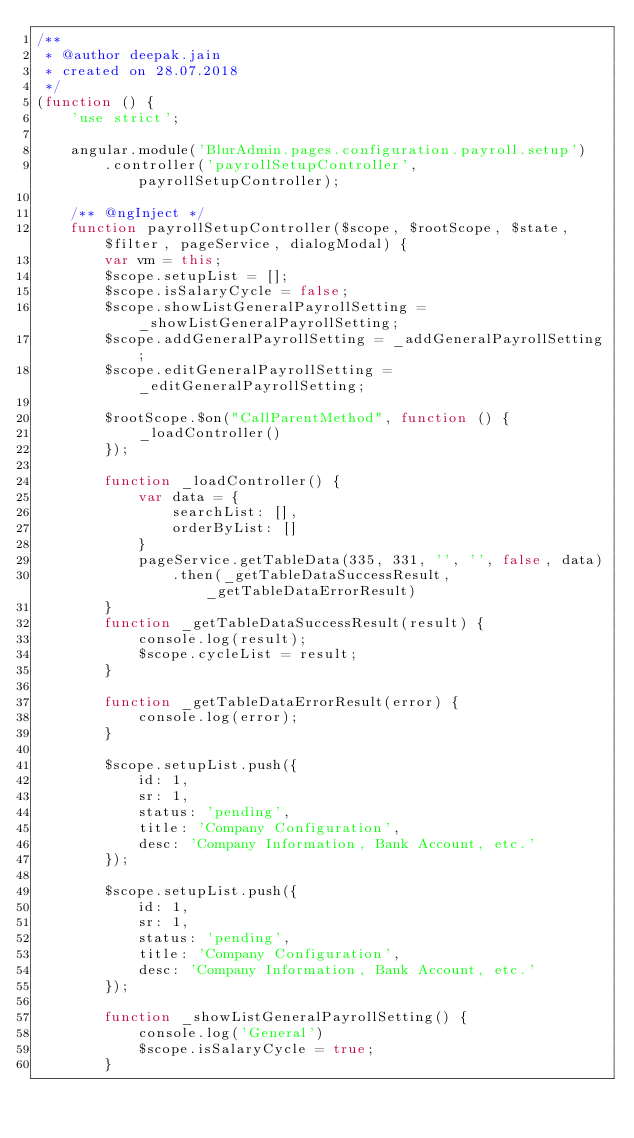<code> <loc_0><loc_0><loc_500><loc_500><_JavaScript_>/**
 * @author deepak.jain
 * created on 28.07.2018
 */
(function () {
    'use strict';

    angular.module('BlurAdmin.pages.configuration.payroll.setup')
        .controller('payrollSetupController', payrollSetupController);

    /** @ngInject */
    function payrollSetupController($scope, $rootScope, $state, $filter, pageService, dialogModal) {
        var vm = this;
        $scope.setupList = [];
        $scope.isSalaryCycle = false;
        $scope.showListGeneralPayrollSetting = _showListGeneralPayrollSetting;
        $scope.addGeneralPayrollSetting = _addGeneralPayrollSetting;
        $scope.editGeneralPayrollSetting = _editGeneralPayrollSetting;

        $rootScope.$on("CallParentMethod", function () {
            _loadController()
        }); 

        function _loadController() {
            var data = {
                searchList: [],
                orderByList: []
            }
            pageService.getTableData(335, 331, '', '', false, data)
                .then(_getTableDataSuccessResult, _getTableDataErrorResult)
        }
        function _getTableDataSuccessResult(result) {
            console.log(result);
            $scope.cycleList = result;
        }

        function _getTableDataErrorResult(error) {
            console.log(error);
        }

        $scope.setupList.push({
            id: 1,
            sr: 1,
            status: 'pending',
            title: 'Company Configuration',
            desc: 'Company Information, Bank Account, etc.'
        });

        $scope.setupList.push({
            id: 1,
            sr: 1,
            status: 'pending',
            title: 'Company Configuration',
            desc: 'Company Information, Bank Account, etc.'
        });

        function _showListGeneralPayrollSetting() {
            console.log('General')
            $scope.isSalaryCycle = true;
        }
</code> 